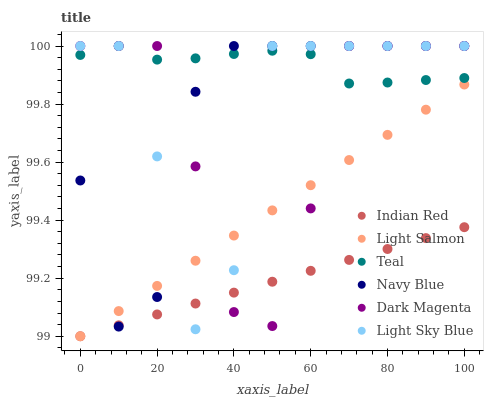Does Indian Red have the minimum area under the curve?
Answer yes or no. Yes. Does Teal have the maximum area under the curve?
Answer yes or no. Yes. Does Navy Blue have the minimum area under the curve?
Answer yes or no. No. Does Navy Blue have the maximum area under the curve?
Answer yes or no. No. Is Indian Red the smoothest?
Answer yes or no. Yes. Is Light Sky Blue the roughest?
Answer yes or no. Yes. Is Navy Blue the smoothest?
Answer yes or no. No. Is Navy Blue the roughest?
Answer yes or no. No. Does Light Salmon have the lowest value?
Answer yes or no. Yes. Does Navy Blue have the lowest value?
Answer yes or no. No. Does Dark Magenta have the highest value?
Answer yes or no. Yes. Does Indian Red have the highest value?
Answer yes or no. No. Is Light Salmon less than Teal?
Answer yes or no. Yes. Is Teal greater than Indian Red?
Answer yes or no. Yes. Does Light Sky Blue intersect Light Salmon?
Answer yes or no. Yes. Is Light Sky Blue less than Light Salmon?
Answer yes or no. No. Is Light Sky Blue greater than Light Salmon?
Answer yes or no. No. Does Light Salmon intersect Teal?
Answer yes or no. No. 